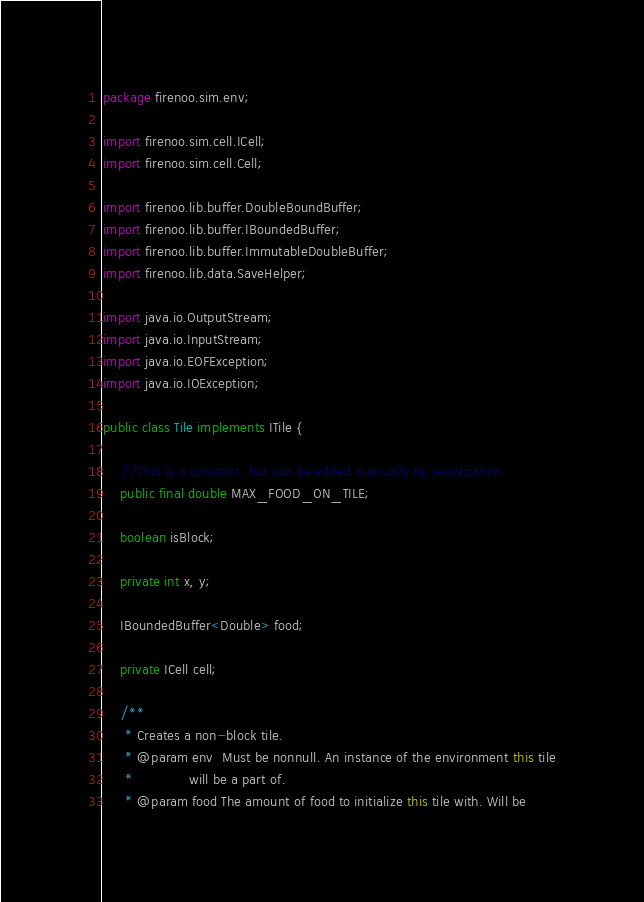Convert code to text. <code><loc_0><loc_0><loc_500><loc_500><_Java_>package firenoo.sim.env;

import firenoo.sim.cell.ICell;
import firenoo.sim.cell.Cell;

import firenoo.lib.buffer.DoubleBoundBuffer;
import firenoo.lib.buffer.IBoundedBuffer;
import firenoo.lib.buffer.ImmutableDoubleBuffer;
import firenoo.lib.data.SaveHelper;

import java.io.OutputStream;
import java.io.InputStream;
import java.io.EOFException;
import java.io.IOException;

public class Tile implements ITile {
    
    //This is a constant, but can be edited manually by serialization
    public final double MAX_FOOD_ON_TILE;

    boolean isBlock;

    private int x, y;
        
    IBoundedBuffer<Double> food;

    private ICell cell;

    /**
     * Creates a non-block tile.
     * @param env  Must be nonnull. An instance of the environment this tile
     *             will be a part of.
     * @param food The amount of food to initialize this tile with. Will be</code> 